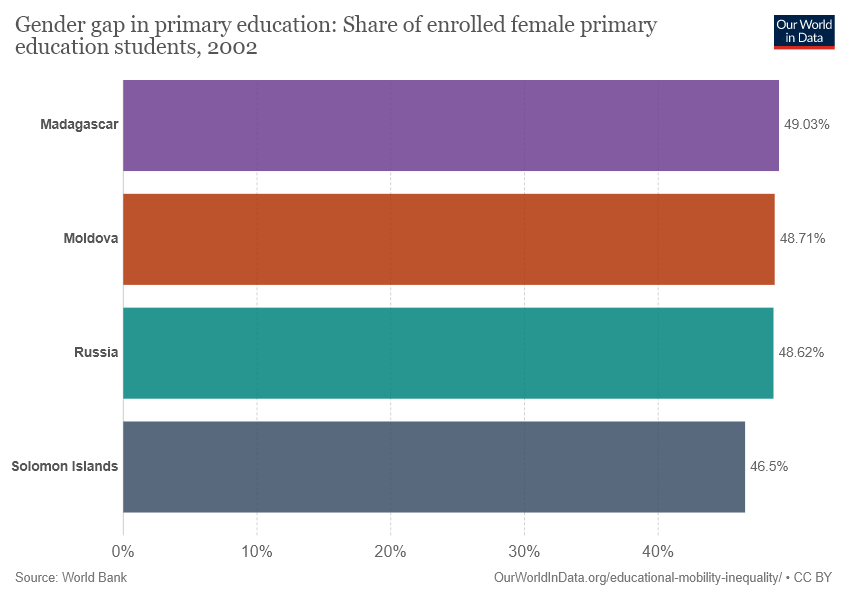Highlight a few significant elements in this photo. The value of the longest bar is 49.03. The average of the longest and smallest bar values is approximately 47.765. 